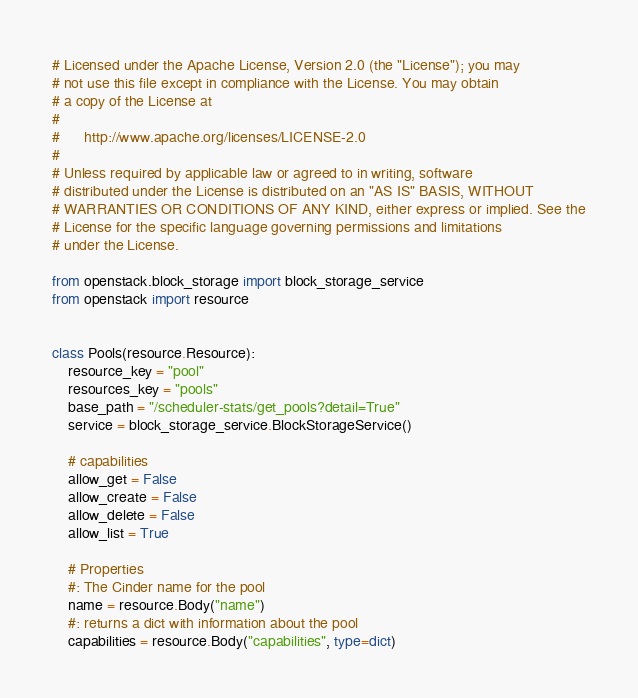Convert code to text. <code><loc_0><loc_0><loc_500><loc_500><_Python_># Licensed under the Apache License, Version 2.0 (the "License"); you may
# not use this file except in compliance with the License. You may obtain
# a copy of the License at
#
#      http://www.apache.org/licenses/LICENSE-2.0
#
# Unless required by applicable law or agreed to in writing, software
# distributed under the License is distributed on an "AS IS" BASIS, WITHOUT
# WARRANTIES OR CONDITIONS OF ANY KIND, either express or implied. See the
# License for the specific language governing permissions and limitations
# under the License.

from openstack.block_storage import block_storage_service
from openstack import resource


class Pools(resource.Resource):
    resource_key = "pool"
    resources_key = "pools"
    base_path = "/scheduler-stats/get_pools?detail=True"
    service = block_storage_service.BlockStorageService()

    # capabilities
    allow_get = False
    allow_create = False
    allow_delete = False
    allow_list = True

    # Properties
    #: The Cinder name for the pool
    name = resource.Body("name")
    #: returns a dict with information about the pool
    capabilities = resource.Body("capabilities", type=dict)
</code> 